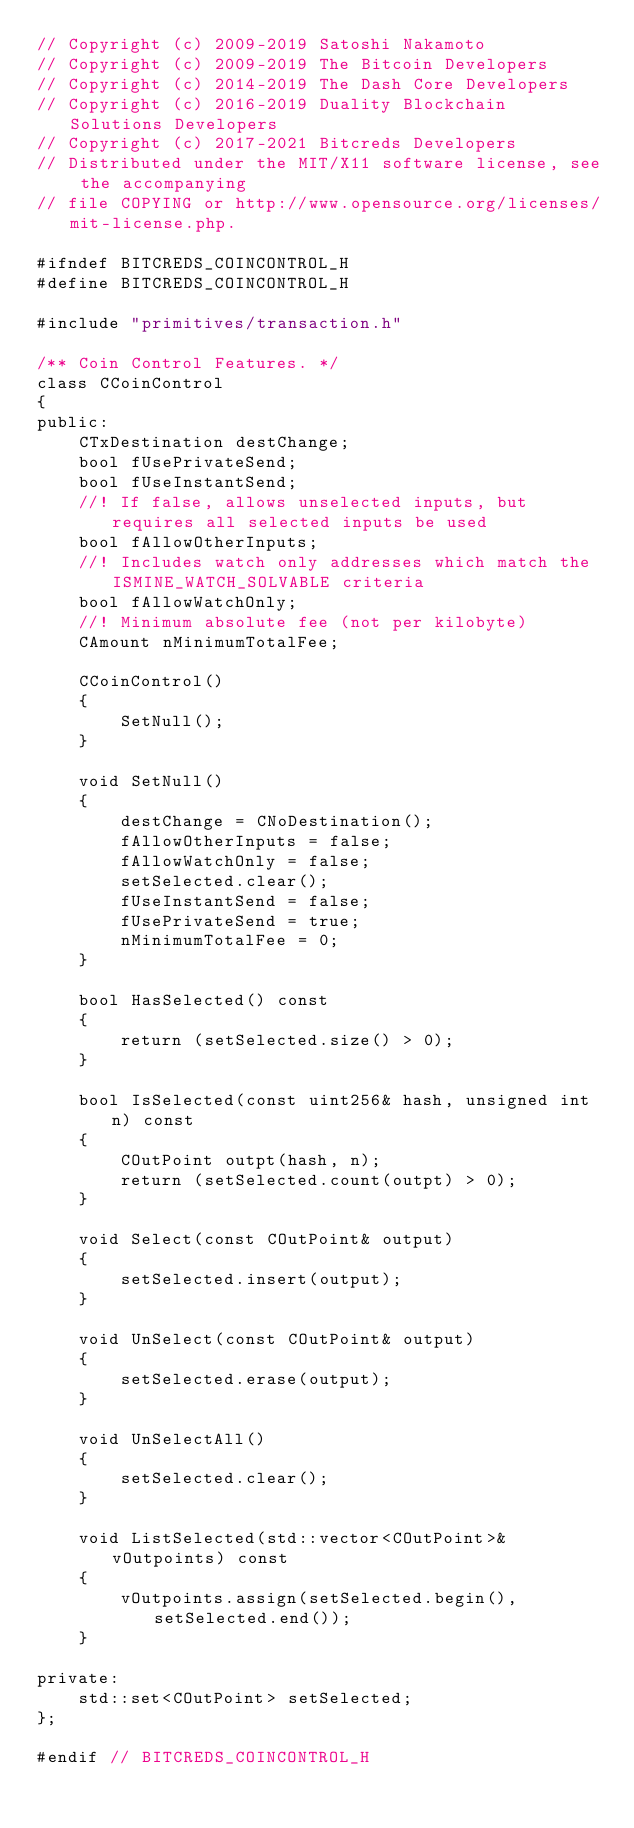Convert code to text. <code><loc_0><loc_0><loc_500><loc_500><_C_>// Copyright (c) 2009-2019 Satoshi Nakamoto
// Copyright (c) 2009-2019 The Bitcoin Developers
// Copyright (c) 2014-2019 The Dash Core Developers
// Copyright (c) 2016-2019 Duality Blockchain Solutions Developers
// Copyright (c) 2017-2021 Bitcreds Developers
// Distributed under the MIT/X11 software license, see the accompanying
// file COPYING or http://www.opensource.org/licenses/mit-license.php.

#ifndef BITCREDS_COINCONTROL_H
#define BITCREDS_COINCONTROL_H

#include "primitives/transaction.h"

/** Coin Control Features. */
class CCoinControl
{
public:
    CTxDestination destChange;
    bool fUsePrivateSend;
    bool fUseInstantSend;
    //! If false, allows unselected inputs, but requires all selected inputs be used
    bool fAllowOtherInputs;
    //! Includes watch only addresses which match the ISMINE_WATCH_SOLVABLE criteria
    bool fAllowWatchOnly;
    //! Minimum absolute fee (not per kilobyte)
    CAmount nMinimumTotalFee;

    CCoinControl()
    {
        SetNull();
    }

    void SetNull()
    {
        destChange = CNoDestination();
        fAllowOtherInputs = false;
        fAllowWatchOnly = false;
        setSelected.clear();
        fUseInstantSend = false;
        fUsePrivateSend = true;
        nMinimumTotalFee = 0;
    }

    bool HasSelected() const
    {
        return (setSelected.size() > 0);
    }

    bool IsSelected(const uint256& hash, unsigned int n) const
    {
        COutPoint outpt(hash, n);
        return (setSelected.count(outpt) > 0);
    }

    void Select(const COutPoint& output)
    {
        setSelected.insert(output);
    }

    void UnSelect(const COutPoint& output)
    {
        setSelected.erase(output);
    }

    void UnSelectAll()
    {
        setSelected.clear();
    }

    void ListSelected(std::vector<COutPoint>& vOutpoints) const
    {
        vOutpoints.assign(setSelected.begin(), setSelected.end());
    }

private:
    std::set<COutPoint> setSelected;
};

#endif // BITCREDS_COINCONTROL_H
</code> 